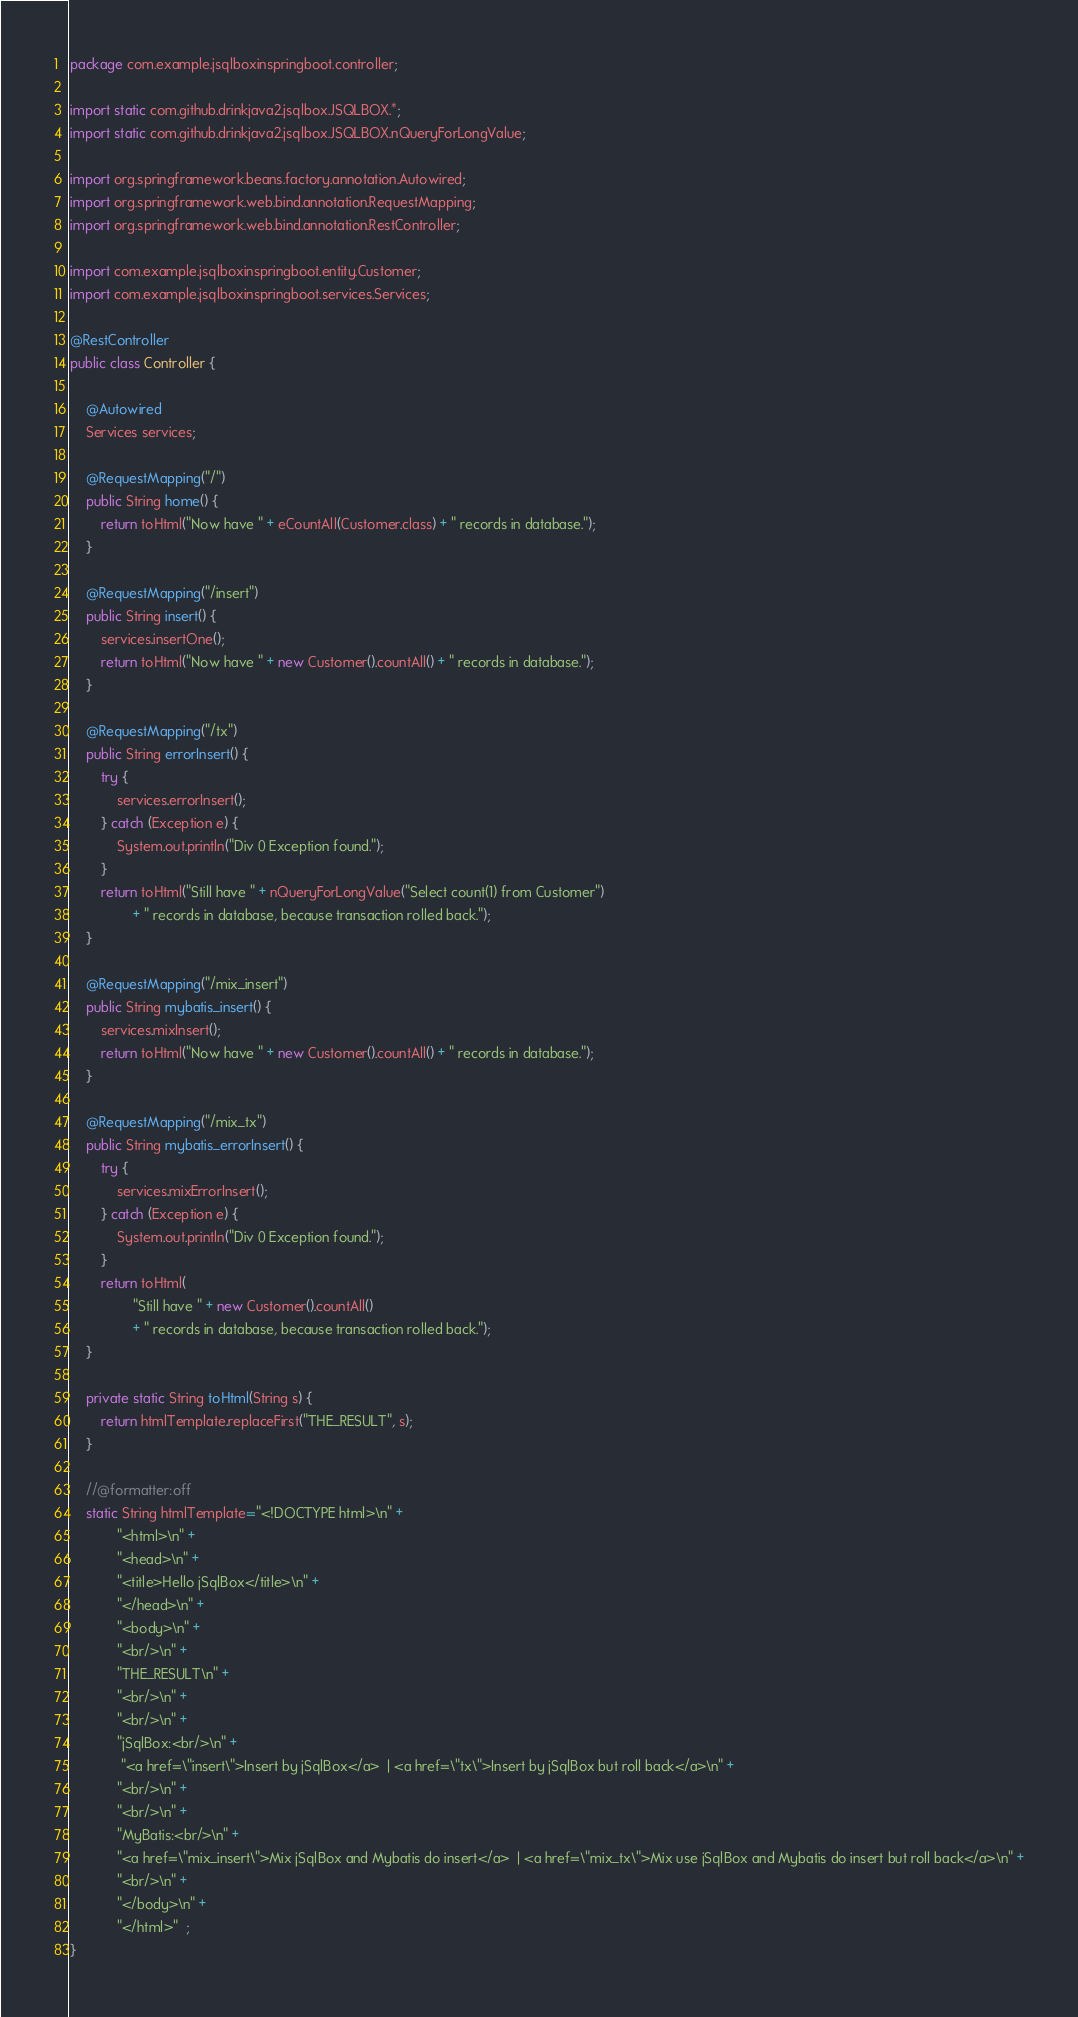<code> <loc_0><loc_0><loc_500><loc_500><_Java_>package com.example.jsqlboxinspringboot.controller;

import static com.github.drinkjava2.jsqlbox.JSQLBOX.*;
import static com.github.drinkjava2.jsqlbox.JSQLBOX.nQueryForLongValue;

import org.springframework.beans.factory.annotation.Autowired;
import org.springframework.web.bind.annotation.RequestMapping;
import org.springframework.web.bind.annotation.RestController;

import com.example.jsqlboxinspringboot.entity.Customer;
import com.example.jsqlboxinspringboot.services.Services;

@RestController
public class Controller {

	@Autowired
	Services services;

	@RequestMapping("/")
	public String home() {
		return toHtml("Now have " + eCountAll(Customer.class) + " records in database.");
	}

	@RequestMapping("/insert")
	public String insert() {
		services.insertOne();
		return toHtml("Now have " + new Customer().countAll() + " records in database.");
	}

	@RequestMapping("/tx")
	public String errorInsert() {
		try {
			services.errorInsert();
		} catch (Exception e) {
			System.out.println("Div 0 Exception found.");
		}
		return toHtml("Still have " + nQueryForLongValue("Select count(1) from Customer")
				+ " records in database, because transaction rolled back.");
	}

	@RequestMapping("/mix_insert")
	public String mybatis_insert() { 
		services.mixInsert();
		return toHtml("Now have " + new Customer().countAll() + " records in database.");
	}

	@RequestMapping("/mix_tx")
	public String mybatis_errorInsert() {
		try {
			services.mixErrorInsert();
		} catch (Exception e) {
			System.out.println("Div 0 Exception found.");
		}
		return toHtml(
				"Still have " + new Customer().countAll()
				+ " records in database, because transaction rolled back.");
	}

	private static String toHtml(String s) {
		return htmlTemplate.replaceFirst("THE_RESULT", s);
	}

	//@formatter:off
	static String htmlTemplate="<!DOCTYPE html>\n" + 
			"<html>\n" + 
			"<head>\n" + 
			"<title>Hello jSqlBox</title>\n" + 
			"</head>\n" + 
			"<body>\n" + 
			"<br/>\n" + 
			"THE_RESULT\n" + 
			"<br/>\n" + 
			"<br/>\n" + 
			"jSqlBox:<br/>\n" + 
			 "<a href=\"insert\">Insert by jSqlBox</a>  | <a href=\"tx\">Insert by jSqlBox but roll back</a>\n" + 
			"<br/>\n" + 
			"<br/>\n" + 
			"MyBatis:<br/>\n" + 
			"<a href=\"mix_insert\">Mix jSqlBox and Mybatis do insert</a>  | <a href=\"mix_tx\">Mix use jSqlBox and Mybatis do insert but roll back</a>\n" +
			"<br/>\n" + 
			"</body>\n" + 
			"</html>"  ;
}</code> 